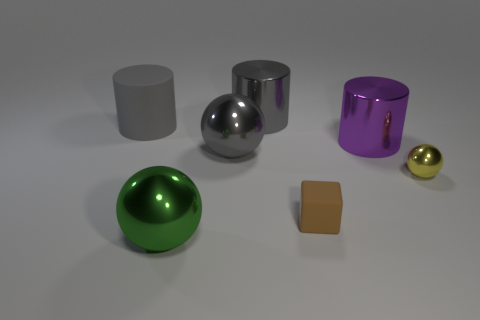There is a metallic object that is left of the gray shiny thing that is in front of the big cylinder that is to the right of the matte cube; what color is it? The color of the metallic object to the left of the gray shiny sphere, in front of the large cylinder, and to the right of the matte cube is indeed green. It appears to have a reflective surface that mirrors the colors and light of its surroundings, which gives it a vibrant and luminous appearance. 